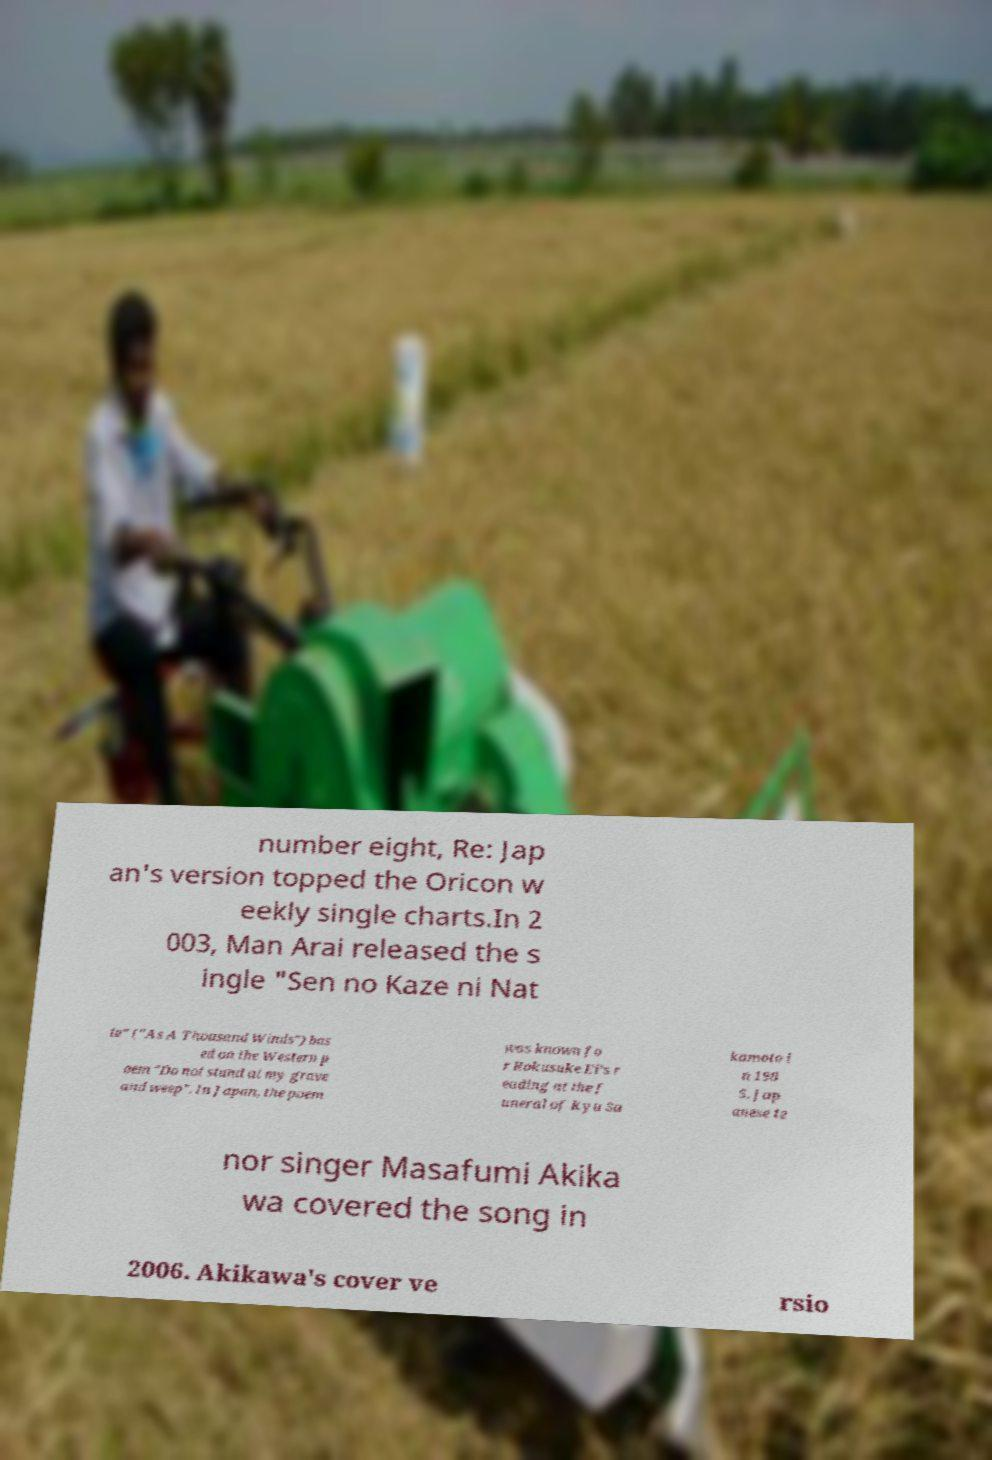What messages or text are displayed in this image? I need them in a readable, typed format. number eight, Re: Jap an's version topped the Oricon w eekly single charts.In 2 003, Man Arai released the s ingle "Sen no Kaze ni Nat te" ("As A Thousand Winds") bas ed on the Western p oem "Do not stand at my grave and weep". In Japan, the poem was known fo r Rokusuke Ei's r eading at the f uneral of Kyu Sa kamoto i n 198 5. Jap anese te nor singer Masafumi Akika wa covered the song in 2006. Akikawa's cover ve rsio 